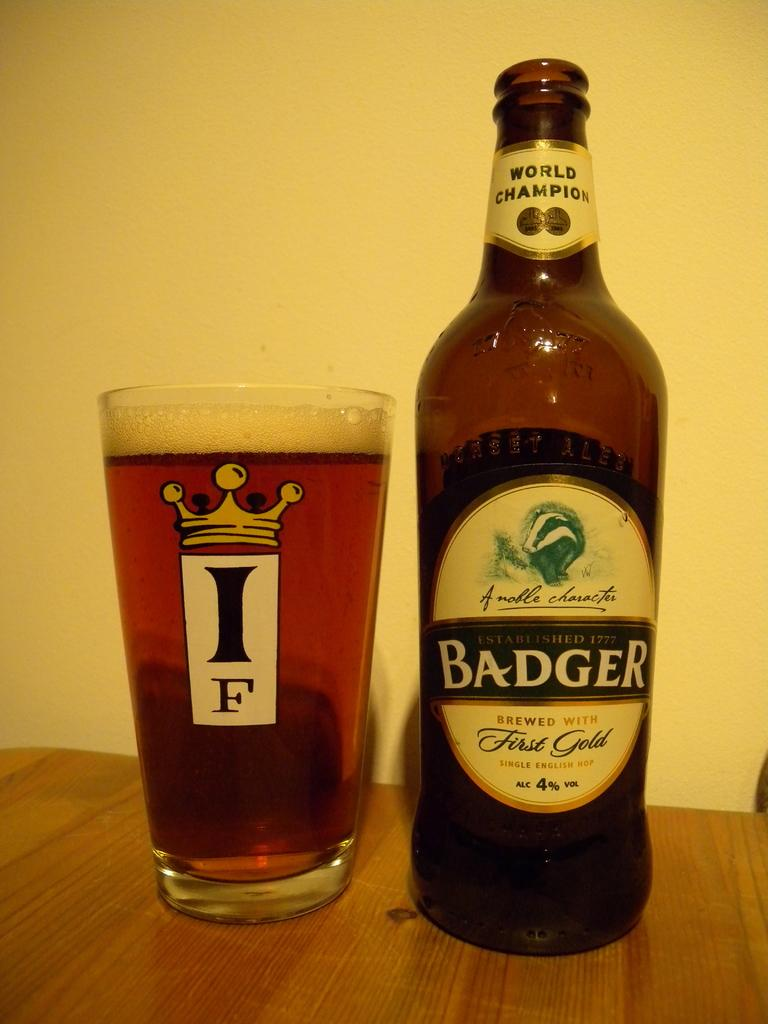<image>
Write a terse but informative summary of the picture. a bottle of badger established in 1777 which is brewed with first gold 